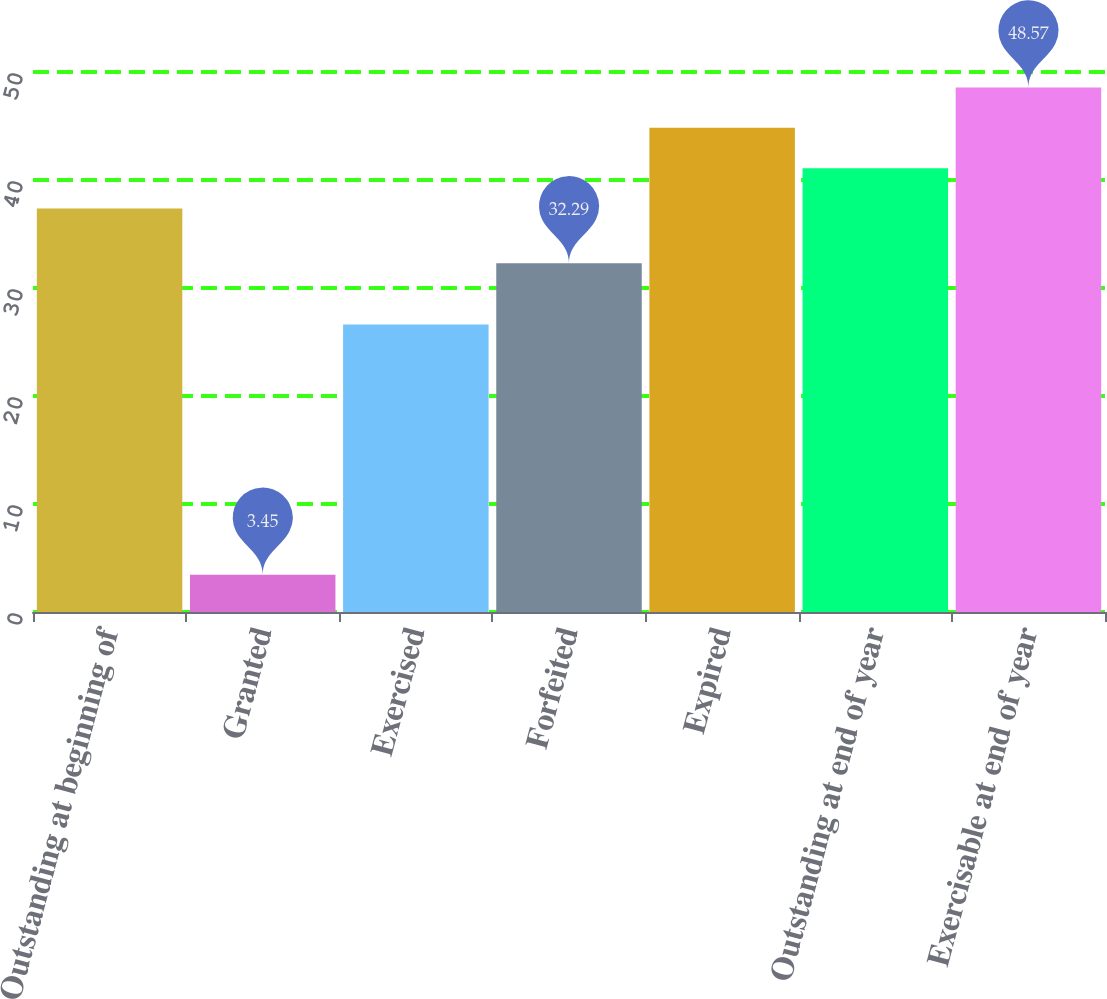Convert chart. <chart><loc_0><loc_0><loc_500><loc_500><bar_chart><fcel>Outstanding at beginning of<fcel>Granted<fcel>Exercised<fcel>Forfeited<fcel>Expired<fcel>Outstanding at end of year<fcel>Exercisable at end of year<nl><fcel>37.35<fcel>3.45<fcel>26.63<fcel>32.29<fcel>44.83<fcel>41.09<fcel>48.57<nl></chart> 